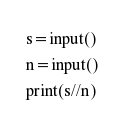Convert code to text. <code><loc_0><loc_0><loc_500><loc_500><_Python_>s=input()
n=input()
print(s//n)</code> 